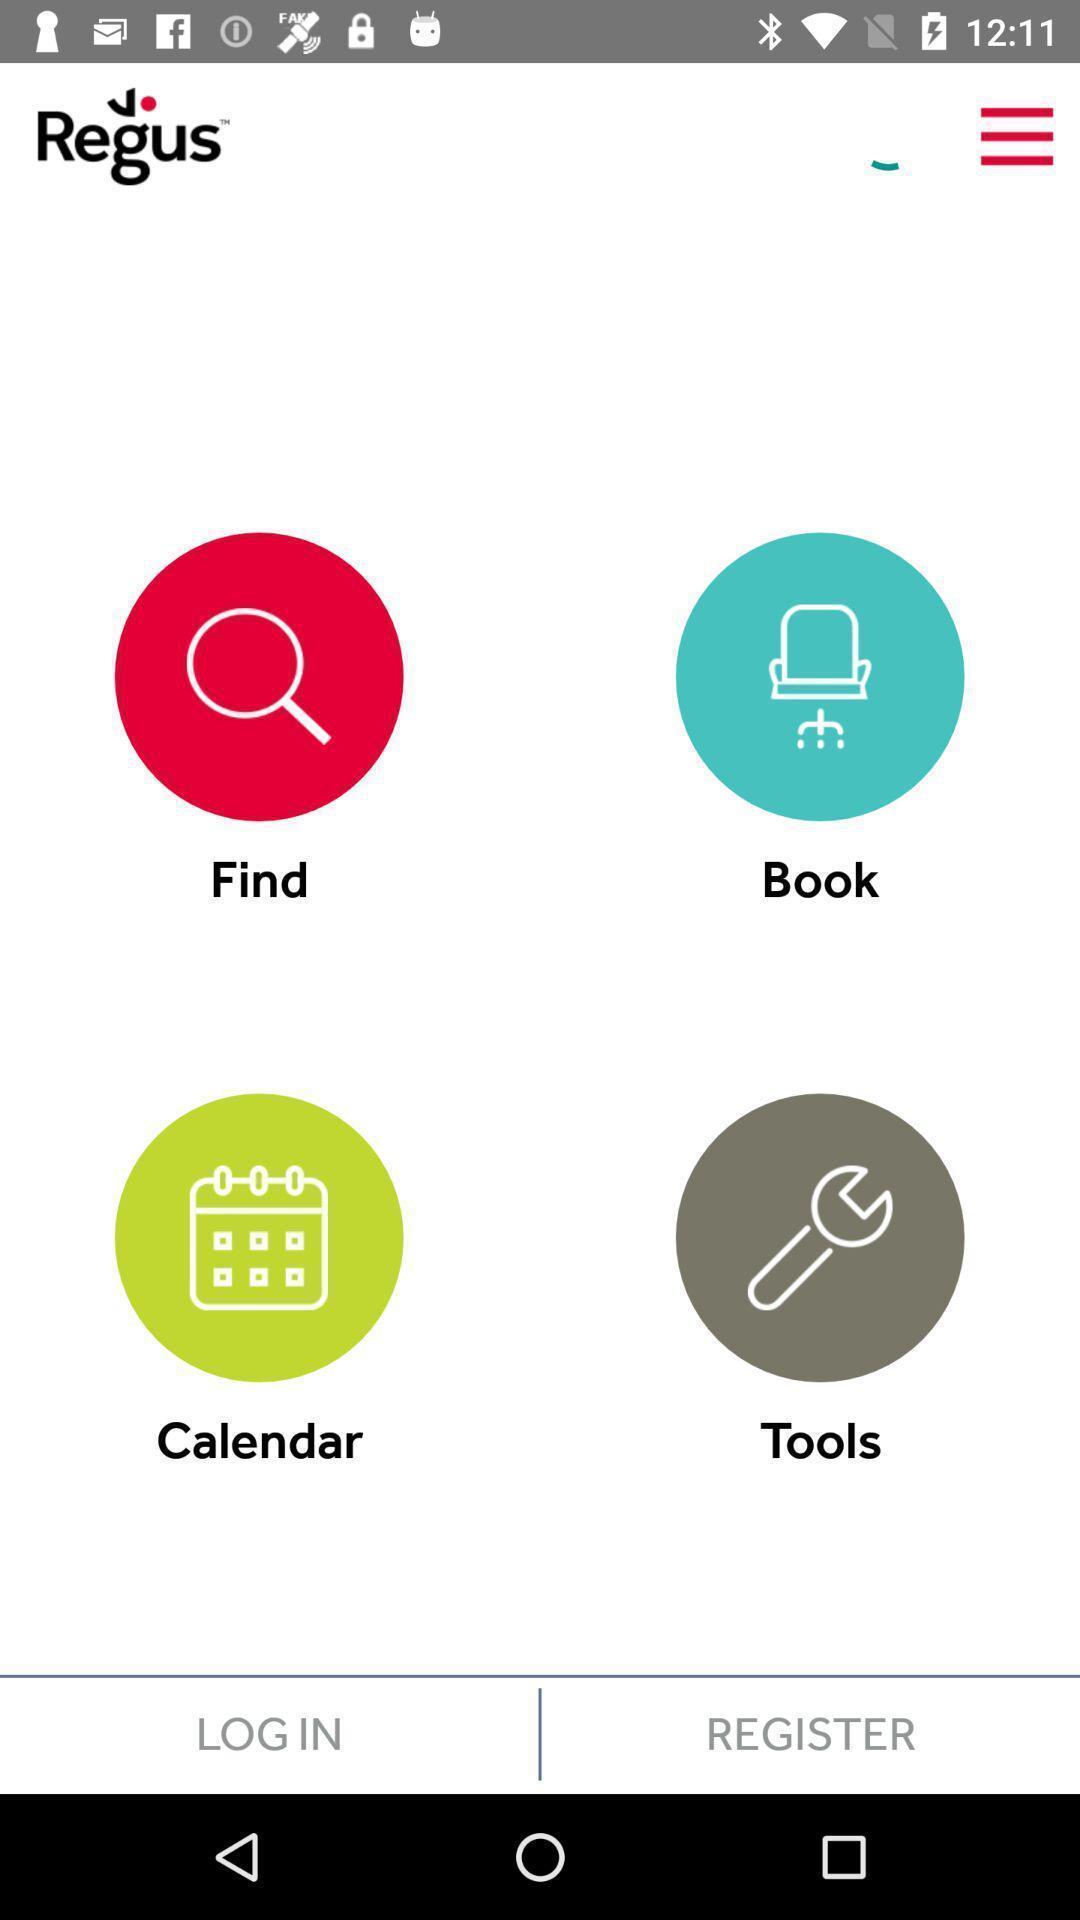Tell me what you see in this picture. Page showing various options. 